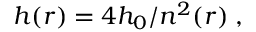<formula> <loc_0><loc_0><loc_500><loc_500>h ( r ) = { 4 h _ { 0 } } / { n ^ { 2 } ( r ) } \, ,</formula> 